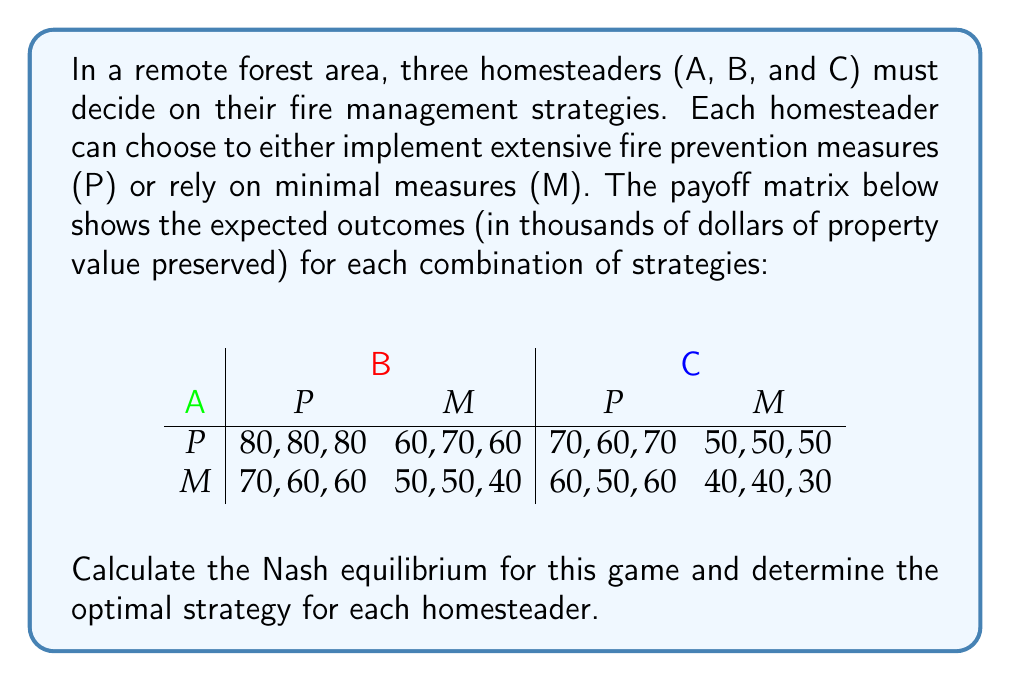What is the answer to this math problem? To find the Nash equilibrium, we need to analyze each homesteader's best response to the other players' strategies:

1. For Homesteader A:
   - If B and C both choose P: $80 > 70$, so A chooses P
   - If B chooses P and C chooses M: $60 > 50$, so A chooses P
   - If B chooses M and C chooses P: $70 > 60$, so A chooses P
   - If B and C both choose M: $50 > 40$, so A chooses P

2. For Homesteader B:
   - If A and C both choose P: $80 > 60$, so B chooses P
   - If A chooses P and C chooses M: $70 > 50$, so B chooses P
   - If A chooses M and C chooses P: $60 > 50$, so B chooses P
   - If A and C both choose M: $50 > 40$, so B chooses P

3. For Homesteader C:
   - If A and B both choose P: $80 > 60$, so C chooses P
   - If A chooses P and B chooses M: $60 > 50$, so C chooses P
   - If A chooses M and B chooses P: $70 > 60$, so C chooses P
   - If A and B both choose M: $40 > 30$, so C chooses P

We can see that regardless of what the other homesteaders choose, each homesteader's best strategy is always to implement extensive fire prevention measures (P). This means there is a unique Nash equilibrium in pure strategies.

To verify, let's check if any homesteader has an incentive to deviate from the strategy profile (P, P, P):

- If A deviates to M: $70 < 80$, so no incentive to deviate
- If B deviates to M: $60 < 80$, so no incentive to deviate
- If C deviates to M: $60 < 80$, so no incentive to deviate

Since no homesteader can improve their payoff by unilaterally changing their strategy, (P, P, P) is confirmed as the Nash equilibrium.
Answer: The Nash equilibrium for this game is (P, P, P), where all three homesteaders choose to implement extensive fire prevention measures (P). This strategy profile yields a payoff of 80,000 dollars in preserved property value for each homesteader. 